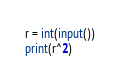Convert code to text. <code><loc_0><loc_0><loc_500><loc_500><_Python_>r = int(input())
print(r^2)</code> 